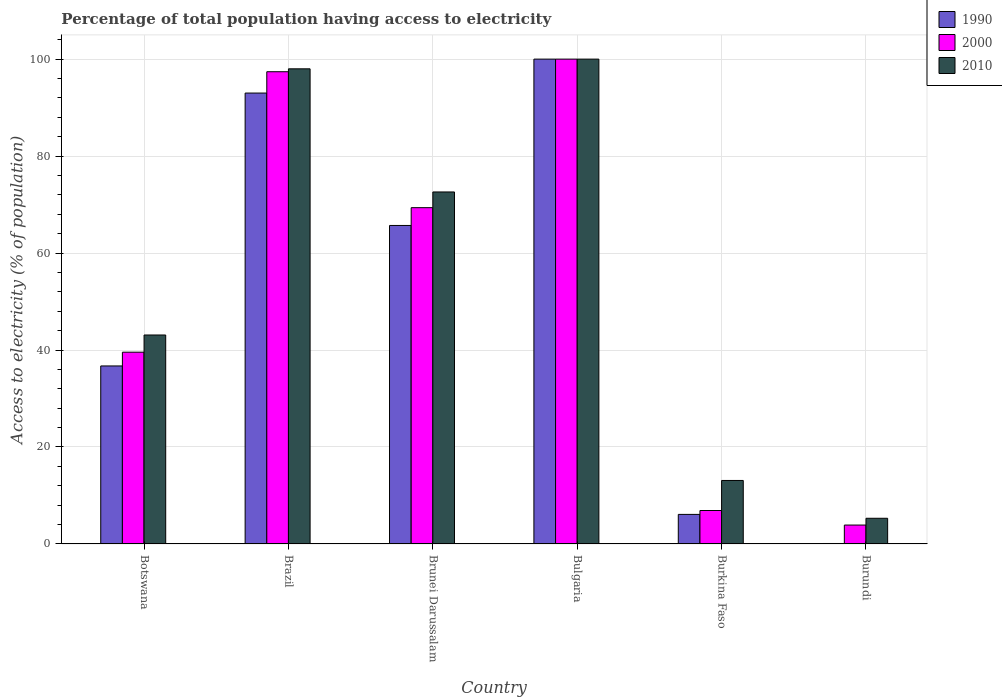How many bars are there on the 4th tick from the left?
Your answer should be very brief. 3. How many bars are there on the 2nd tick from the right?
Keep it short and to the point. 3. What is the label of the 1st group of bars from the left?
Provide a succinct answer. Botswana. In how many cases, is the number of bars for a given country not equal to the number of legend labels?
Offer a terse response. 0. What is the percentage of population that have access to electricity in 2000 in Brunei Darussalam?
Your response must be concise. 69.36. In which country was the percentage of population that have access to electricity in 1990 minimum?
Give a very brief answer. Burundi. What is the total percentage of population that have access to electricity in 1990 in the graph?
Make the answer very short. 301.61. What is the difference between the percentage of population that have access to electricity in 2000 in Brazil and that in Brunei Darussalam?
Provide a succinct answer. 28.04. What is the difference between the percentage of population that have access to electricity in 2010 in Brazil and the percentage of population that have access to electricity in 2000 in Bulgaria?
Give a very brief answer. -2. What is the average percentage of population that have access to electricity in 2010 per country?
Your answer should be very brief. 55.35. What is the difference between the percentage of population that have access to electricity of/in 1990 and percentage of population that have access to electricity of/in 2000 in Burkina Faso?
Your answer should be very brief. -0.8. In how many countries, is the percentage of population that have access to electricity in 2000 greater than 76 %?
Keep it short and to the point. 2. What is the ratio of the percentage of population that have access to electricity in 2000 in Brunei Darussalam to that in Burkina Faso?
Your answer should be very brief. 10.05. Is the percentage of population that have access to electricity in 2010 in Botswana less than that in Burkina Faso?
Provide a short and direct response. No. Is the difference between the percentage of population that have access to electricity in 1990 in Botswana and Burkina Faso greater than the difference between the percentage of population that have access to electricity in 2000 in Botswana and Burkina Faso?
Give a very brief answer. No. What is the difference between the highest and the second highest percentage of population that have access to electricity in 2000?
Ensure brevity in your answer.  -2.6. What is the difference between the highest and the lowest percentage of population that have access to electricity in 2010?
Offer a very short reply. 94.7. What does the 1st bar from the left in Burundi represents?
Your answer should be very brief. 1990. What does the 1st bar from the right in Bulgaria represents?
Provide a short and direct response. 2010. How many bars are there?
Offer a very short reply. 18. What is the difference between two consecutive major ticks on the Y-axis?
Ensure brevity in your answer.  20. Are the values on the major ticks of Y-axis written in scientific E-notation?
Your response must be concise. No. Does the graph contain any zero values?
Offer a very short reply. No. Does the graph contain grids?
Give a very brief answer. Yes. How many legend labels are there?
Keep it short and to the point. 3. What is the title of the graph?
Keep it short and to the point. Percentage of total population having access to electricity. What is the label or title of the X-axis?
Offer a terse response. Country. What is the label or title of the Y-axis?
Provide a short and direct response. Access to electricity (% of population). What is the Access to electricity (% of population) in 1990 in Botswana?
Offer a terse response. 36.72. What is the Access to electricity (% of population) of 2000 in Botswana?
Provide a succinct answer. 39.56. What is the Access to electricity (% of population) of 2010 in Botswana?
Give a very brief answer. 43.1. What is the Access to electricity (% of population) in 1990 in Brazil?
Your answer should be compact. 93. What is the Access to electricity (% of population) in 2000 in Brazil?
Provide a short and direct response. 97.4. What is the Access to electricity (% of population) of 2010 in Brazil?
Your answer should be very brief. 98. What is the Access to electricity (% of population) in 1990 in Brunei Darussalam?
Offer a very short reply. 65.69. What is the Access to electricity (% of population) of 2000 in Brunei Darussalam?
Provide a short and direct response. 69.36. What is the Access to electricity (% of population) in 2010 in Brunei Darussalam?
Your response must be concise. 72.6. What is the Access to electricity (% of population) of 1990 in Bulgaria?
Offer a terse response. 100. What is the Access to electricity (% of population) of 2000 in Bulgaria?
Ensure brevity in your answer.  100. What is the Access to electricity (% of population) of 2010 in Bulgaria?
Ensure brevity in your answer.  100. What is the Access to electricity (% of population) in 1990 in Burkina Faso?
Your answer should be compact. 6.1. What is the Access to electricity (% of population) in 2000 in Burkina Faso?
Ensure brevity in your answer.  6.9. Across all countries, what is the maximum Access to electricity (% of population) of 1990?
Offer a very short reply. 100. Across all countries, what is the maximum Access to electricity (% of population) in 2000?
Your answer should be very brief. 100. Across all countries, what is the minimum Access to electricity (% of population) in 1990?
Make the answer very short. 0.1. Across all countries, what is the minimum Access to electricity (% of population) of 2010?
Make the answer very short. 5.3. What is the total Access to electricity (% of population) of 1990 in the graph?
Offer a very short reply. 301.61. What is the total Access to electricity (% of population) in 2000 in the graph?
Your answer should be very brief. 317.12. What is the total Access to electricity (% of population) of 2010 in the graph?
Provide a short and direct response. 332.1. What is the difference between the Access to electricity (% of population) in 1990 in Botswana and that in Brazil?
Give a very brief answer. -56.28. What is the difference between the Access to electricity (% of population) of 2000 in Botswana and that in Brazil?
Offer a very short reply. -57.84. What is the difference between the Access to electricity (% of population) of 2010 in Botswana and that in Brazil?
Keep it short and to the point. -54.9. What is the difference between the Access to electricity (% of population) in 1990 in Botswana and that in Brunei Darussalam?
Keep it short and to the point. -28.98. What is the difference between the Access to electricity (% of population) of 2000 in Botswana and that in Brunei Darussalam?
Offer a very short reply. -29.81. What is the difference between the Access to electricity (% of population) in 2010 in Botswana and that in Brunei Darussalam?
Your answer should be compact. -29.5. What is the difference between the Access to electricity (% of population) of 1990 in Botswana and that in Bulgaria?
Give a very brief answer. -63.28. What is the difference between the Access to electricity (% of population) in 2000 in Botswana and that in Bulgaria?
Keep it short and to the point. -60.44. What is the difference between the Access to electricity (% of population) of 2010 in Botswana and that in Bulgaria?
Your answer should be compact. -56.9. What is the difference between the Access to electricity (% of population) of 1990 in Botswana and that in Burkina Faso?
Provide a succinct answer. 30.62. What is the difference between the Access to electricity (% of population) in 2000 in Botswana and that in Burkina Faso?
Make the answer very short. 32.66. What is the difference between the Access to electricity (% of population) in 1990 in Botswana and that in Burundi?
Provide a short and direct response. 36.62. What is the difference between the Access to electricity (% of population) of 2000 in Botswana and that in Burundi?
Keep it short and to the point. 35.66. What is the difference between the Access to electricity (% of population) in 2010 in Botswana and that in Burundi?
Make the answer very short. 37.8. What is the difference between the Access to electricity (% of population) of 1990 in Brazil and that in Brunei Darussalam?
Give a very brief answer. 27.31. What is the difference between the Access to electricity (% of population) of 2000 in Brazil and that in Brunei Darussalam?
Your answer should be compact. 28.04. What is the difference between the Access to electricity (% of population) of 2010 in Brazil and that in Brunei Darussalam?
Ensure brevity in your answer.  25.4. What is the difference between the Access to electricity (% of population) of 1990 in Brazil and that in Burkina Faso?
Provide a short and direct response. 86.9. What is the difference between the Access to electricity (% of population) in 2000 in Brazil and that in Burkina Faso?
Offer a terse response. 90.5. What is the difference between the Access to electricity (% of population) in 2010 in Brazil and that in Burkina Faso?
Your answer should be very brief. 84.9. What is the difference between the Access to electricity (% of population) of 1990 in Brazil and that in Burundi?
Make the answer very short. 92.9. What is the difference between the Access to electricity (% of population) in 2000 in Brazil and that in Burundi?
Make the answer very short. 93.5. What is the difference between the Access to electricity (% of population) in 2010 in Brazil and that in Burundi?
Offer a very short reply. 92.7. What is the difference between the Access to electricity (% of population) in 1990 in Brunei Darussalam and that in Bulgaria?
Provide a short and direct response. -34.31. What is the difference between the Access to electricity (% of population) of 2000 in Brunei Darussalam and that in Bulgaria?
Your response must be concise. -30.64. What is the difference between the Access to electricity (% of population) of 2010 in Brunei Darussalam and that in Bulgaria?
Keep it short and to the point. -27.4. What is the difference between the Access to electricity (% of population) in 1990 in Brunei Darussalam and that in Burkina Faso?
Ensure brevity in your answer.  59.59. What is the difference between the Access to electricity (% of population) of 2000 in Brunei Darussalam and that in Burkina Faso?
Your answer should be very brief. 62.46. What is the difference between the Access to electricity (% of population) of 2010 in Brunei Darussalam and that in Burkina Faso?
Keep it short and to the point. 59.5. What is the difference between the Access to electricity (% of population) of 1990 in Brunei Darussalam and that in Burundi?
Ensure brevity in your answer.  65.59. What is the difference between the Access to electricity (% of population) of 2000 in Brunei Darussalam and that in Burundi?
Your answer should be very brief. 65.46. What is the difference between the Access to electricity (% of population) of 2010 in Brunei Darussalam and that in Burundi?
Offer a very short reply. 67.3. What is the difference between the Access to electricity (% of population) of 1990 in Bulgaria and that in Burkina Faso?
Keep it short and to the point. 93.9. What is the difference between the Access to electricity (% of population) in 2000 in Bulgaria and that in Burkina Faso?
Keep it short and to the point. 93.1. What is the difference between the Access to electricity (% of population) in 2010 in Bulgaria and that in Burkina Faso?
Your response must be concise. 86.9. What is the difference between the Access to electricity (% of population) of 1990 in Bulgaria and that in Burundi?
Your response must be concise. 99.9. What is the difference between the Access to electricity (% of population) of 2000 in Bulgaria and that in Burundi?
Give a very brief answer. 96.1. What is the difference between the Access to electricity (% of population) of 2010 in Bulgaria and that in Burundi?
Your answer should be compact. 94.7. What is the difference between the Access to electricity (% of population) of 2010 in Burkina Faso and that in Burundi?
Offer a terse response. 7.8. What is the difference between the Access to electricity (% of population) of 1990 in Botswana and the Access to electricity (% of population) of 2000 in Brazil?
Offer a very short reply. -60.68. What is the difference between the Access to electricity (% of population) in 1990 in Botswana and the Access to electricity (% of population) in 2010 in Brazil?
Make the answer very short. -61.28. What is the difference between the Access to electricity (% of population) in 2000 in Botswana and the Access to electricity (% of population) in 2010 in Brazil?
Your answer should be compact. -58.44. What is the difference between the Access to electricity (% of population) of 1990 in Botswana and the Access to electricity (% of population) of 2000 in Brunei Darussalam?
Ensure brevity in your answer.  -32.65. What is the difference between the Access to electricity (% of population) in 1990 in Botswana and the Access to electricity (% of population) in 2010 in Brunei Darussalam?
Your answer should be compact. -35.88. What is the difference between the Access to electricity (% of population) in 2000 in Botswana and the Access to electricity (% of population) in 2010 in Brunei Darussalam?
Your response must be concise. -33.04. What is the difference between the Access to electricity (% of population) in 1990 in Botswana and the Access to electricity (% of population) in 2000 in Bulgaria?
Ensure brevity in your answer.  -63.28. What is the difference between the Access to electricity (% of population) in 1990 in Botswana and the Access to electricity (% of population) in 2010 in Bulgaria?
Make the answer very short. -63.28. What is the difference between the Access to electricity (% of population) of 2000 in Botswana and the Access to electricity (% of population) of 2010 in Bulgaria?
Make the answer very short. -60.44. What is the difference between the Access to electricity (% of population) in 1990 in Botswana and the Access to electricity (% of population) in 2000 in Burkina Faso?
Your answer should be very brief. 29.82. What is the difference between the Access to electricity (% of population) in 1990 in Botswana and the Access to electricity (% of population) in 2010 in Burkina Faso?
Provide a short and direct response. 23.62. What is the difference between the Access to electricity (% of population) in 2000 in Botswana and the Access to electricity (% of population) in 2010 in Burkina Faso?
Your answer should be compact. 26.46. What is the difference between the Access to electricity (% of population) of 1990 in Botswana and the Access to electricity (% of population) of 2000 in Burundi?
Keep it short and to the point. 32.82. What is the difference between the Access to electricity (% of population) of 1990 in Botswana and the Access to electricity (% of population) of 2010 in Burundi?
Keep it short and to the point. 31.42. What is the difference between the Access to electricity (% of population) of 2000 in Botswana and the Access to electricity (% of population) of 2010 in Burundi?
Your answer should be compact. 34.26. What is the difference between the Access to electricity (% of population) in 1990 in Brazil and the Access to electricity (% of population) in 2000 in Brunei Darussalam?
Provide a short and direct response. 23.64. What is the difference between the Access to electricity (% of population) in 1990 in Brazil and the Access to electricity (% of population) in 2010 in Brunei Darussalam?
Your answer should be compact. 20.4. What is the difference between the Access to electricity (% of population) in 2000 in Brazil and the Access to electricity (% of population) in 2010 in Brunei Darussalam?
Offer a very short reply. 24.8. What is the difference between the Access to electricity (% of population) in 1990 in Brazil and the Access to electricity (% of population) in 2000 in Burkina Faso?
Provide a succinct answer. 86.1. What is the difference between the Access to electricity (% of population) of 1990 in Brazil and the Access to electricity (% of population) of 2010 in Burkina Faso?
Ensure brevity in your answer.  79.9. What is the difference between the Access to electricity (% of population) of 2000 in Brazil and the Access to electricity (% of population) of 2010 in Burkina Faso?
Make the answer very short. 84.3. What is the difference between the Access to electricity (% of population) in 1990 in Brazil and the Access to electricity (% of population) in 2000 in Burundi?
Make the answer very short. 89.1. What is the difference between the Access to electricity (% of population) of 1990 in Brazil and the Access to electricity (% of population) of 2010 in Burundi?
Offer a terse response. 87.7. What is the difference between the Access to electricity (% of population) of 2000 in Brazil and the Access to electricity (% of population) of 2010 in Burundi?
Provide a short and direct response. 92.1. What is the difference between the Access to electricity (% of population) of 1990 in Brunei Darussalam and the Access to electricity (% of population) of 2000 in Bulgaria?
Give a very brief answer. -34.31. What is the difference between the Access to electricity (% of population) in 1990 in Brunei Darussalam and the Access to electricity (% of population) in 2010 in Bulgaria?
Provide a succinct answer. -34.31. What is the difference between the Access to electricity (% of population) in 2000 in Brunei Darussalam and the Access to electricity (% of population) in 2010 in Bulgaria?
Keep it short and to the point. -30.64. What is the difference between the Access to electricity (% of population) in 1990 in Brunei Darussalam and the Access to electricity (% of population) in 2000 in Burkina Faso?
Offer a terse response. 58.79. What is the difference between the Access to electricity (% of population) of 1990 in Brunei Darussalam and the Access to electricity (% of population) of 2010 in Burkina Faso?
Your response must be concise. 52.59. What is the difference between the Access to electricity (% of population) in 2000 in Brunei Darussalam and the Access to electricity (% of population) in 2010 in Burkina Faso?
Provide a short and direct response. 56.26. What is the difference between the Access to electricity (% of population) in 1990 in Brunei Darussalam and the Access to electricity (% of population) in 2000 in Burundi?
Make the answer very short. 61.79. What is the difference between the Access to electricity (% of population) of 1990 in Brunei Darussalam and the Access to electricity (% of population) of 2010 in Burundi?
Provide a succinct answer. 60.39. What is the difference between the Access to electricity (% of population) of 2000 in Brunei Darussalam and the Access to electricity (% of population) of 2010 in Burundi?
Make the answer very short. 64.06. What is the difference between the Access to electricity (% of population) of 1990 in Bulgaria and the Access to electricity (% of population) of 2000 in Burkina Faso?
Your answer should be very brief. 93.1. What is the difference between the Access to electricity (% of population) in 1990 in Bulgaria and the Access to electricity (% of population) in 2010 in Burkina Faso?
Ensure brevity in your answer.  86.9. What is the difference between the Access to electricity (% of population) of 2000 in Bulgaria and the Access to electricity (% of population) of 2010 in Burkina Faso?
Provide a succinct answer. 86.9. What is the difference between the Access to electricity (% of population) in 1990 in Bulgaria and the Access to electricity (% of population) in 2000 in Burundi?
Offer a terse response. 96.1. What is the difference between the Access to electricity (% of population) of 1990 in Bulgaria and the Access to electricity (% of population) of 2010 in Burundi?
Make the answer very short. 94.7. What is the difference between the Access to electricity (% of population) in 2000 in Bulgaria and the Access to electricity (% of population) in 2010 in Burundi?
Your answer should be compact. 94.7. What is the difference between the Access to electricity (% of population) of 1990 in Burkina Faso and the Access to electricity (% of population) of 2000 in Burundi?
Your answer should be compact. 2.2. What is the average Access to electricity (% of population) of 1990 per country?
Your response must be concise. 50.27. What is the average Access to electricity (% of population) of 2000 per country?
Ensure brevity in your answer.  52.85. What is the average Access to electricity (% of population) in 2010 per country?
Keep it short and to the point. 55.35. What is the difference between the Access to electricity (% of population) of 1990 and Access to electricity (% of population) of 2000 in Botswana?
Give a very brief answer. -2.84. What is the difference between the Access to electricity (% of population) of 1990 and Access to electricity (% of population) of 2010 in Botswana?
Offer a terse response. -6.38. What is the difference between the Access to electricity (% of population) in 2000 and Access to electricity (% of population) in 2010 in Botswana?
Offer a very short reply. -3.54. What is the difference between the Access to electricity (% of population) in 1990 and Access to electricity (% of population) in 2000 in Brazil?
Provide a succinct answer. -4.4. What is the difference between the Access to electricity (% of population) in 1990 and Access to electricity (% of population) in 2010 in Brazil?
Your answer should be compact. -5. What is the difference between the Access to electricity (% of population) of 1990 and Access to electricity (% of population) of 2000 in Brunei Darussalam?
Ensure brevity in your answer.  -3.67. What is the difference between the Access to electricity (% of population) of 1990 and Access to electricity (% of population) of 2010 in Brunei Darussalam?
Your answer should be very brief. -6.91. What is the difference between the Access to electricity (% of population) of 2000 and Access to electricity (% of population) of 2010 in Brunei Darussalam?
Your answer should be very brief. -3.24. What is the difference between the Access to electricity (% of population) of 1990 and Access to electricity (% of population) of 2000 in Bulgaria?
Your answer should be compact. 0. What is the ratio of the Access to electricity (% of population) of 1990 in Botswana to that in Brazil?
Your answer should be very brief. 0.39. What is the ratio of the Access to electricity (% of population) of 2000 in Botswana to that in Brazil?
Make the answer very short. 0.41. What is the ratio of the Access to electricity (% of population) in 2010 in Botswana to that in Brazil?
Give a very brief answer. 0.44. What is the ratio of the Access to electricity (% of population) in 1990 in Botswana to that in Brunei Darussalam?
Your answer should be very brief. 0.56. What is the ratio of the Access to electricity (% of population) of 2000 in Botswana to that in Brunei Darussalam?
Provide a succinct answer. 0.57. What is the ratio of the Access to electricity (% of population) of 2010 in Botswana to that in Brunei Darussalam?
Give a very brief answer. 0.59. What is the ratio of the Access to electricity (% of population) of 1990 in Botswana to that in Bulgaria?
Your answer should be very brief. 0.37. What is the ratio of the Access to electricity (% of population) of 2000 in Botswana to that in Bulgaria?
Give a very brief answer. 0.4. What is the ratio of the Access to electricity (% of population) of 2010 in Botswana to that in Bulgaria?
Offer a terse response. 0.43. What is the ratio of the Access to electricity (% of population) of 1990 in Botswana to that in Burkina Faso?
Your answer should be compact. 6.02. What is the ratio of the Access to electricity (% of population) in 2000 in Botswana to that in Burkina Faso?
Your answer should be very brief. 5.73. What is the ratio of the Access to electricity (% of population) of 2010 in Botswana to that in Burkina Faso?
Your response must be concise. 3.29. What is the ratio of the Access to electricity (% of population) in 1990 in Botswana to that in Burundi?
Offer a very short reply. 367.16. What is the ratio of the Access to electricity (% of population) of 2000 in Botswana to that in Burundi?
Make the answer very short. 10.14. What is the ratio of the Access to electricity (% of population) of 2010 in Botswana to that in Burundi?
Your answer should be compact. 8.13. What is the ratio of the Access to electricity (% of population) in 1990 in Brazil to that in Brunei Darussalam?
Offer a terse response. 1.42. What is the ratio of the Access to electricity (% of population) of 2000 in Brazil to that in Brunei Darussalam?
Your answer should be compact. 1.4. What is the ratio of the Access to electricity (% of population) of 2010 in Brazil to that in Brunei Darussalam?
Your response must be concise. 1.35. What is the ratio of the Access to electricity (% of population) of 2000 in Brazil to that in Bulgaria?
Make the answer very short. 0.97. What is the ratio of the Access to electricity (% of population) of 1990 in Brazil to that in Burkina Faso?
Make the answer very short. 15.25. What is the ratio of the Access to electricity (% of population) in 2000 in Brazil to that in Burkina Faso?
Provide a short and direct response. 14.12. What is the ratio of the Access to electricity (% of population) in 2010 in Brazil to that in Burkina Faso?
Your response must be concise. 7.48. What is the ratio of the Access to electricity (% of population) in 1990 in Brazil to that in Burundi?
Ensure brevity in your answer.  930. What is the ratio of the Access to electricity (% of population) in 2000 in Brazil to that in Burundi?
Your answer should be very brief. 24.97. What is the ratio of the Access to electricity (% of population) of 2010 in Brazil to that in Burundi?
Keep it short and to the point. 18.49. What is the ratio of the Access to electricity (% of population) in 1990 in Brunei Darussalam to that in Bulgaria?
Ensure brevity in your answer.  0.66. What is the ratio of the Access to electricity (% of population) in 2000 in Brunei Darussalam to that in Bulgaria?
Give a very brief answer. 0.69. What is the ratio of the Access to electricity (% of population) in 2010 in Brunei Darussalam to that in Bulgaria?
Provide a short and direct response. 0.73. What is the ratio of the Access to electricity (% of population) of 1990 in Brunei Darussalam to that in Burkina Faso?
Your response must be concise. 10.77. What is the ratio of the Access to electricity (% of population) of 2000 in Brunei Darussalam to that in Burkina Faso?
Offer a very short reply. 10.05. What is the ratio of the Access to electricity (% of population) of 2010 in Brunei Darussalam to that in Burkina Faso?
Ensure brevity in your answer.  5.54. What is the ratio of the Access to electricity (% of population) in 1990 in Brunei Darussalam to that in Burundi?
Keep it short and to the point. 656.91. What is the ratio of the Access to electricity (% of population) in 2000 in Brunei Darussalam to that in Burundi?
Your answer should be very brief. 17.79. What is the ratio of the Access to electricity (% of population) in 2010 in Brunei Darussalam to that in Burundi?
Keep it short and to the point. 13.7. What is the ratio of the Access to electricity (% of population) of 1990 in Bulgaria to that in Burkina Faso?
Your answer should be compact. 16.39. What is the ratio of the Access to electricity (% of population) in 2000 in Bulgaria to that in Burkina Faso?
Give a very brief answer. 14.49. What is the ratio of the Access to electricity (% of population) in 2010 in Bulgaria to that in Burkina Faso?
Offer a very short reply. 7.63. What is the ratio of the Access to electricity (% of population) in 2000 in Bulgaria to that in Burundi?
Offer a terse response. 25.64. What is the ratio of the Access to electricity (% of population) in 2010 in Bulgaria to that in Burundi?
Your answer should be very brief. 18.87. What is the ratio of the Access to electricity (% of population) of 1990 in Burkina Faso to that in Burundi?
Make the answer very short. 61. What is the ratio of the Access to electricity (% of population) in 2000 in Burkina Faso to that in Burundi?
Your answer should be compact. 1.77. What is the ratio of the Access to electricity (% of population) of 2010 in Burkina Faso to that in Burundi?
Your answer should be compact. 2.47. What is the difference between the highest and the second highest Access to electricity (% of population) in 1990?
Offer a very short reply. 7. What is the difference between the highest and the second highest Access to electricity (% of population) of 2000?
Make the answer very short. 2.6. What is the difference between the highest and the lowest Access to electricity (% of population) of 1990?
Your response must be concise. 99.9. What is the difference between the highest and the lowest Access to electricity (% of population) in 2000?
Your response must be concise. 96.1. What is the difference between the highest and the lowest Access to electricity (% of population) of 2010?
Your answer should be very brief. 94.7. 